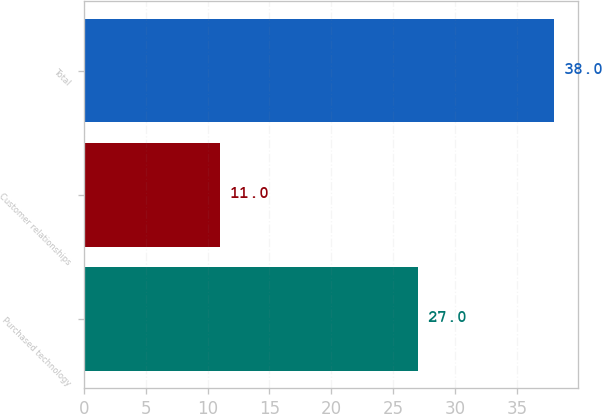<chart> <loc_0><loc_0><loc_500><loc_500><bar_chart><fcel>Purchased technology<fcel>Customer relationships<fcel>Total<nl><fcel>27<fcel>11<fcel>38<nl></chart> 